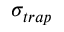Convert formula to latex. <formula><loc_0><loc_0><loc_500><loc_500>\sigma _ { t r a p }</formula> 